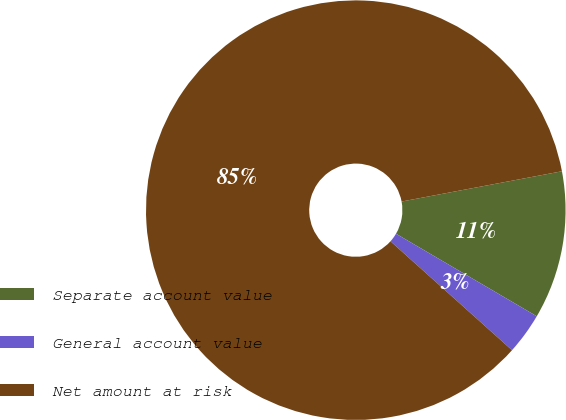Convert chart to OTSL. <chart><loc_0><loc_0><loc_500><loc_500><pie_chart><fcel>Separate account value<fcel>General account value<fcel>Net amount at risk<nl><fcel>11.41%<fcel>3.19%<fcel>85.41%<nl></chart> 